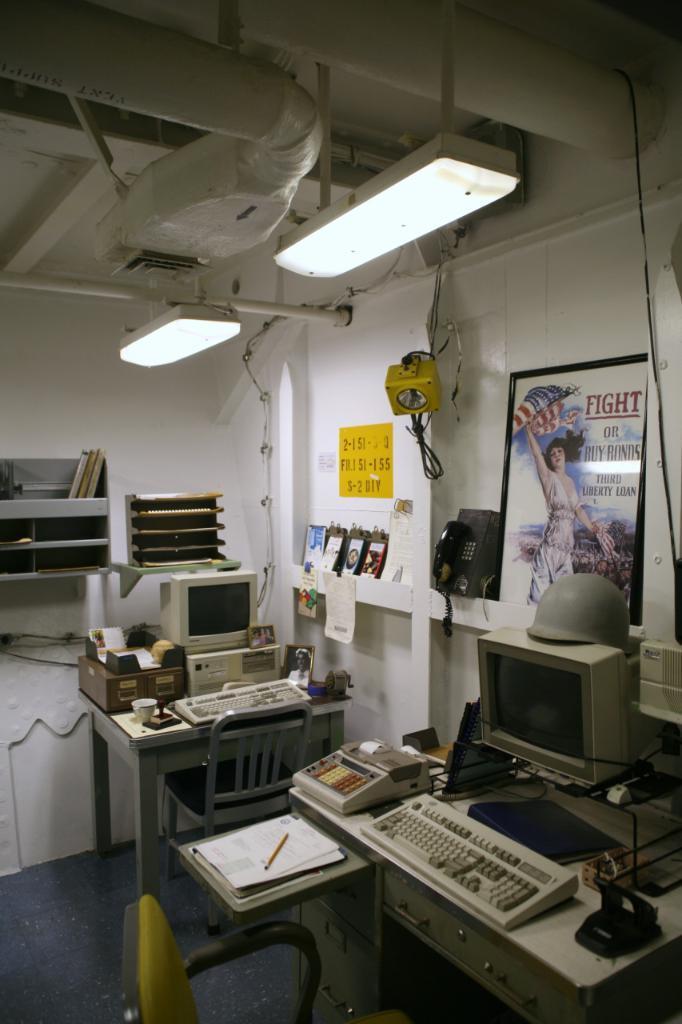Can you describe this image briefly? This picture consists of inside view of the room ,in the room I can see a table , on the table I can see a keypad , system and hat and mouse, paper and pen and machine kept on it and I can see a telephone and light and photo frames visible on the wall in the middle and i can see another table in the middle , on it I can see a key board , system , chair, cup and box kept on it and I can see there are some wooden racks kept in front of the wall ,at the top I can see the roof and pipe lines, lights visible. 